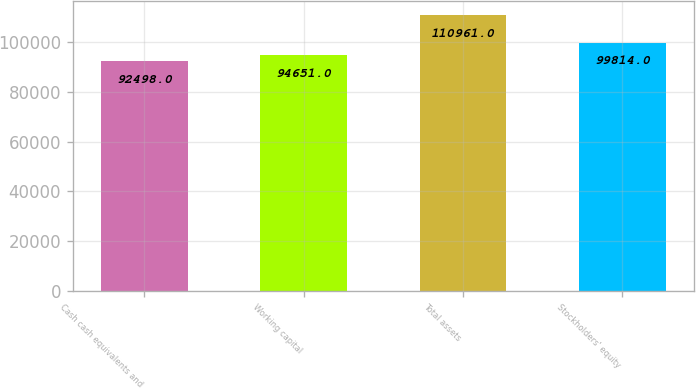Convert chart to OTSL. <chart><loc_0><loc_0><loc_500><loc_500><bar_chart><fcel>Cash cash equivalents and<fcel>Working capital<fcel>Total assets<fcel>Stockholders' equity<nl><fcel>92498<fcel>94651<fcel>110961<fcel>99814<nl></chart> 